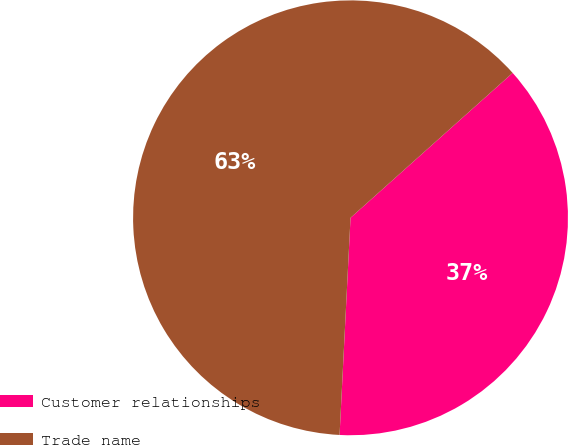Convert chart to OTSL. <chart><loc_0><loc_0><loc_500><loc_500><pie_chart><fcel>Customer relationships<fcel>Trade name<nl><fcel>37.41%<fcel>62.59%<nl></chart> 